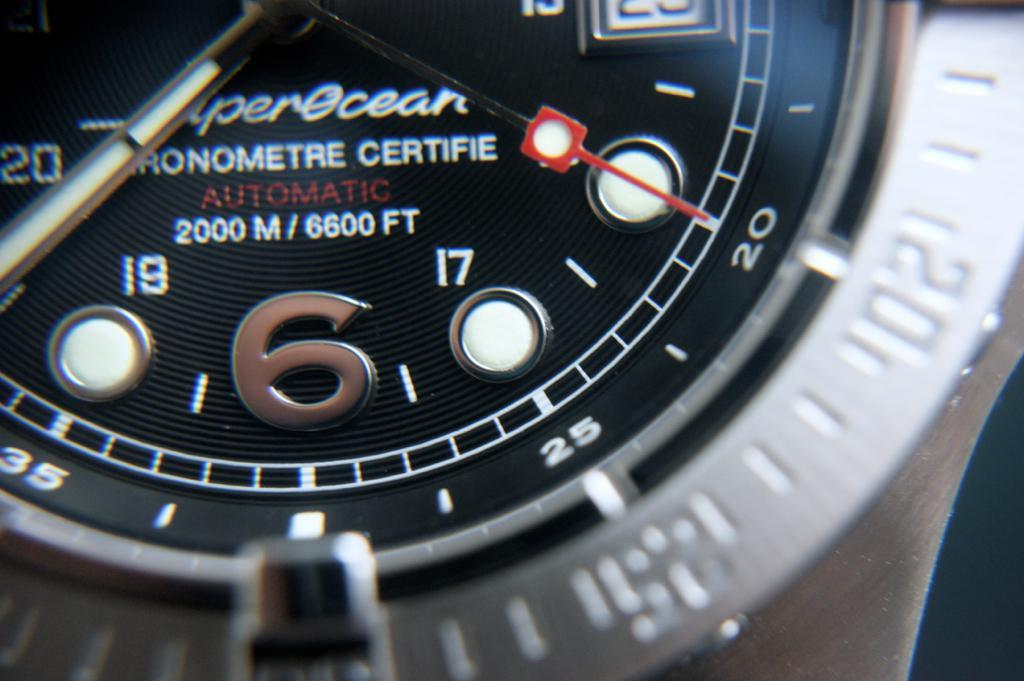<image>
Give a short and clear explanation of the subsequent image. A watch face advertises that it is waterproof up to 2000 meters or 6600 feet. 